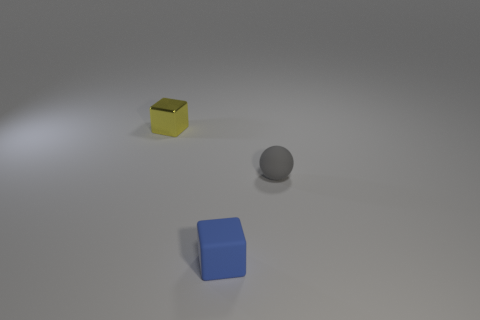Add 2 tiny gray matte spheres. How many objects exist? 5 Subtract all cubes. How many objects are left? 1 Subtract all gray things. Subtract all tiny blue rubber objects. How many objects are left? 1 Add 2 small metal things. How many small metal things are left? 3 Add 2 small cyan things. How many small cyan things exist? 2 Subtract 0 cyan spheres. How many objects are left? 3 